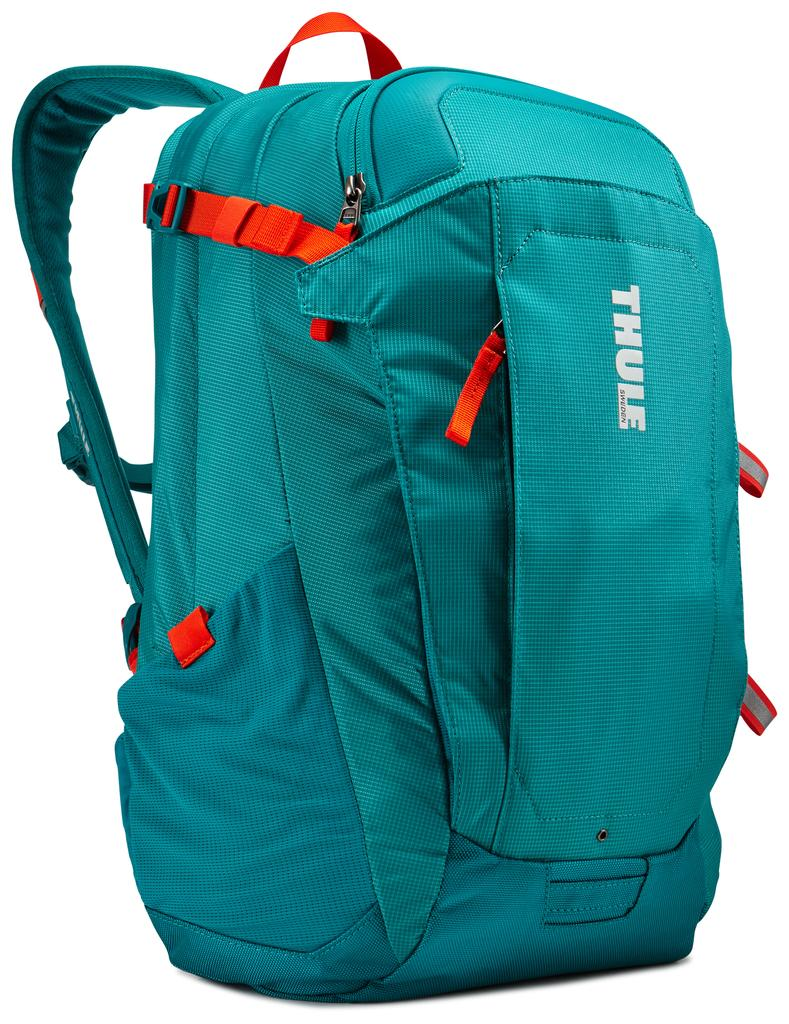<image>
Give a short and clear explanation of the subsequent image. The turquoise backpack with some orange straps is branded with the name Thule. 